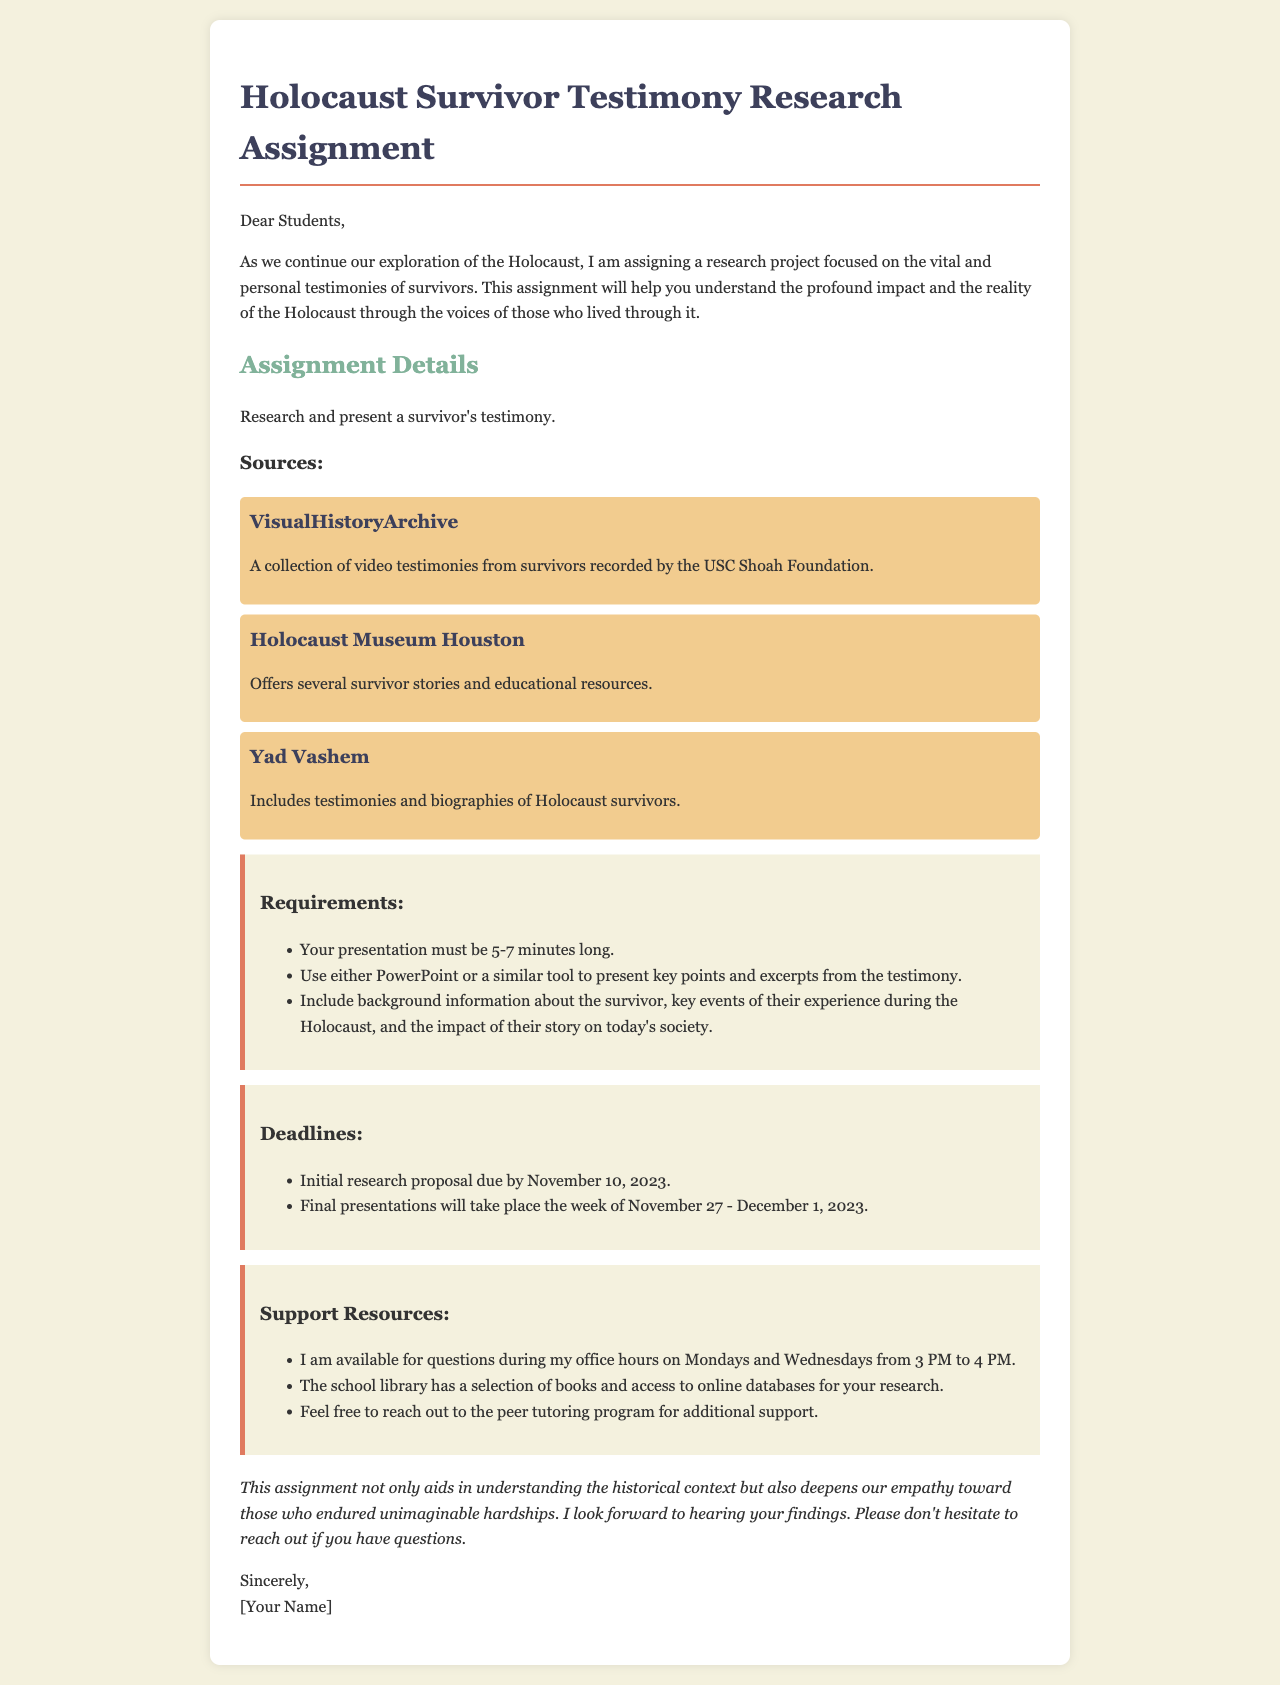What is the title of the assignment? The title of the assignment is specified at the beginning of the document, which is "Holocaust Survivor Testimony Research Assignment."
Answer: Holocaust Survivor Testimony Research Assignment What is the initial research proposal due date? The initial research proposal due date is mentioned in the deadlines section of the document.
Answer: November 10, 2023 How long should the presentation be? The required length for the presentation is stated in the requirements section of the document.
Answer: 5-7 minutes What is one source listed for survivor testimonies? The document lists several sources, and a specific one can be noted from the source section.
Answer: VisualHistoryArchive When will the final presentations take place? The final presentations schedule is provided in the deadlines section of the document.
Answer: Week of November 27 - December 1, 2023 What two tools can be used for the presentation? The requirements specify the tools that can be used for the presentation.
Answer: PowerPoint or a similar tool Where can students find books for research? The document mentions a location for research materials outside of online sources.
Answer: School library What is the teacher's availability for questions? The support resources section provides this information.
Answer: Mondays and Wednesdays from 3 PM to 4 PM What is the main purpose of the assignment? The main purpose is described in the introduction of the document.
Answer: Understand the profound impact and the reality of the Holocaust 